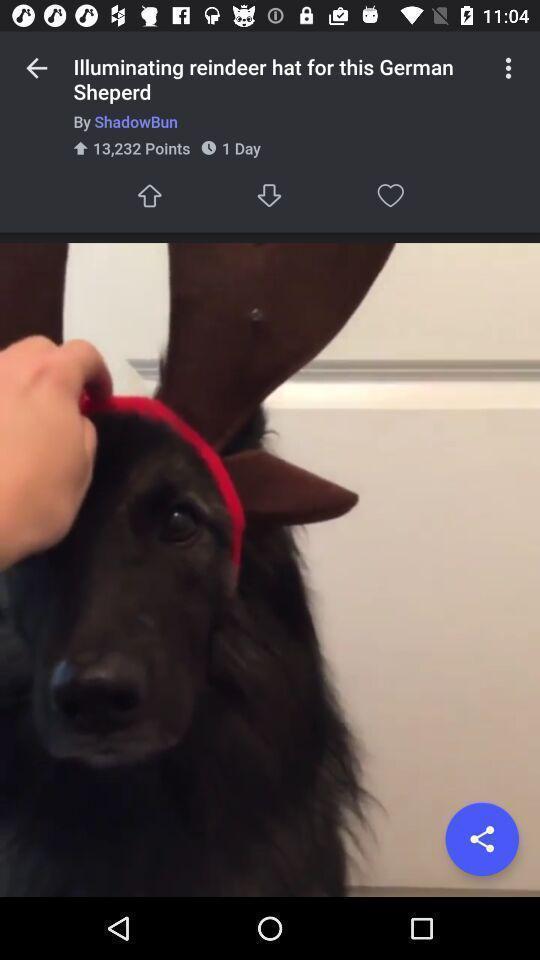Tell me about the visual elements in this screen capture. Page showing an image on an entertainment app. 